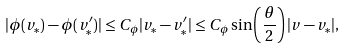<formula> <loc_0><loc_0><loc_500><loc_500>| \phi ( v _ { \ast } ) - \phi ( v ^ { \prime } _ { \ast } ) | \leq C _ { \phi } | v _ { \ast } - v ^ { \prime } _ { \ast } | \leq C _ { \phi } \sin \left ( \frac { \theta } { 2 } \right ) | v - v _ { \ast } | ,</formula> 